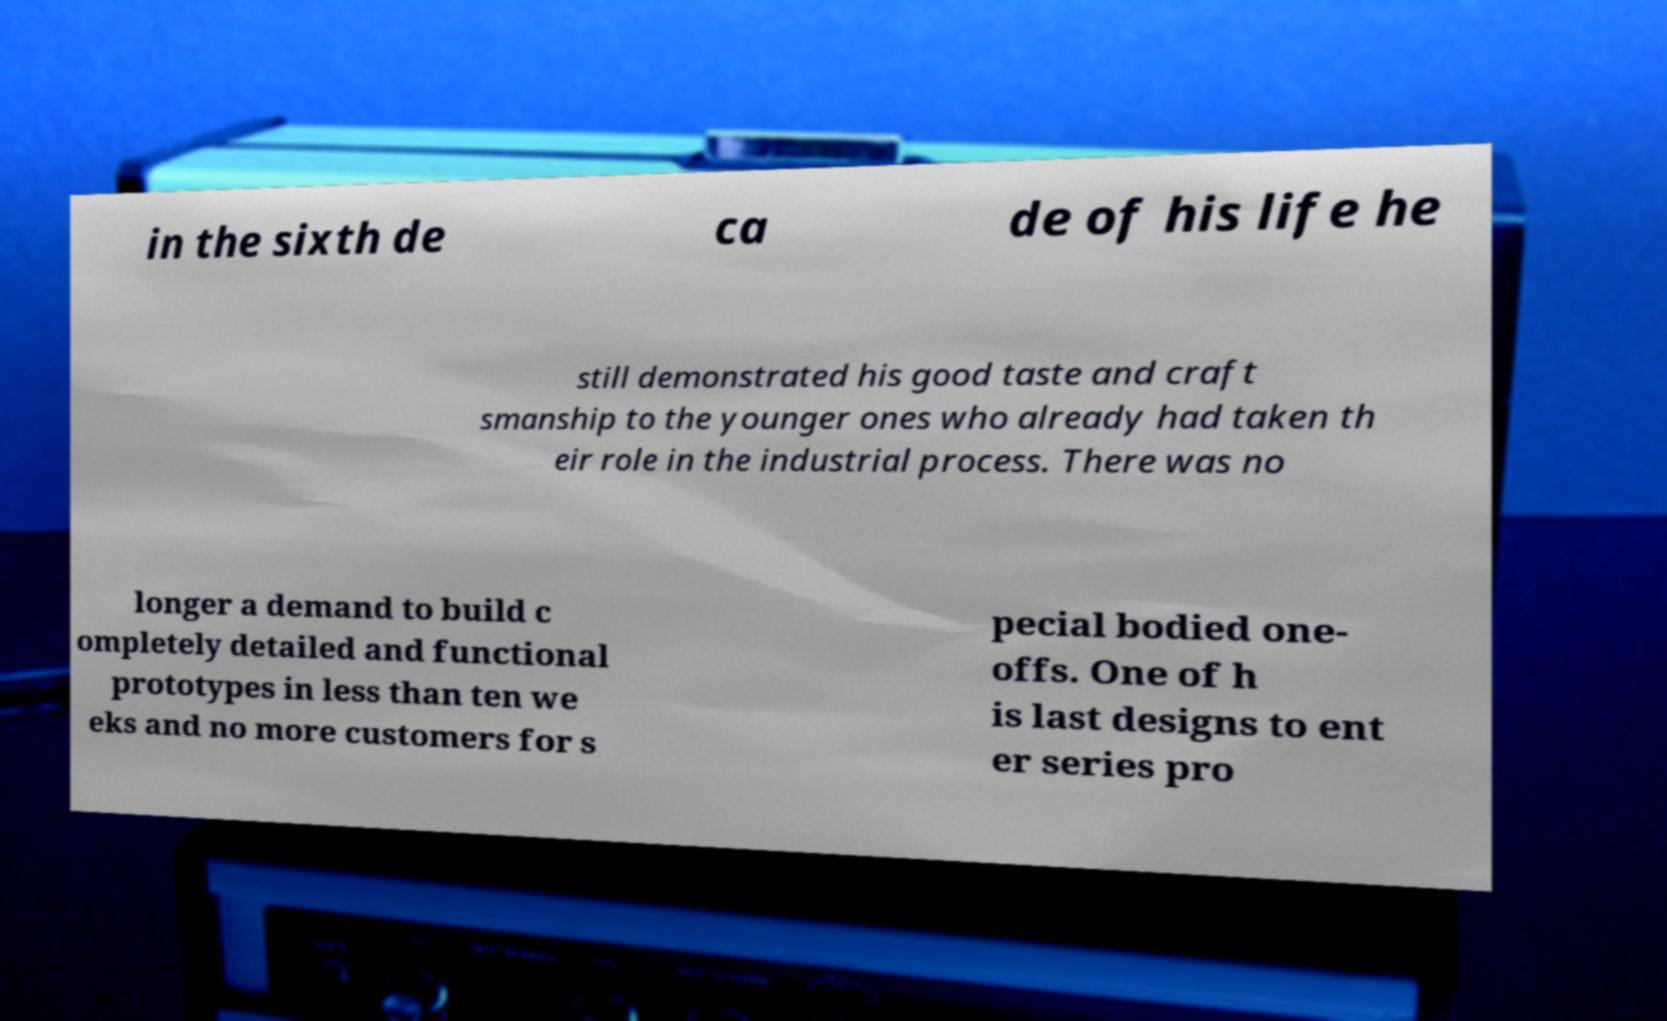Please identify and transcribe the text found in this image. in the sixth de ca de of his life he still demonstrated his good taste and craft smanship to the younger ones who already had taken th eir role in the industrial process. There was no longer a demand to build c ompletely detailed and functional prototypes in less than ten we eks and no more customers for s pecial bodied one- offs. One of h is last designs to ent er series pro 